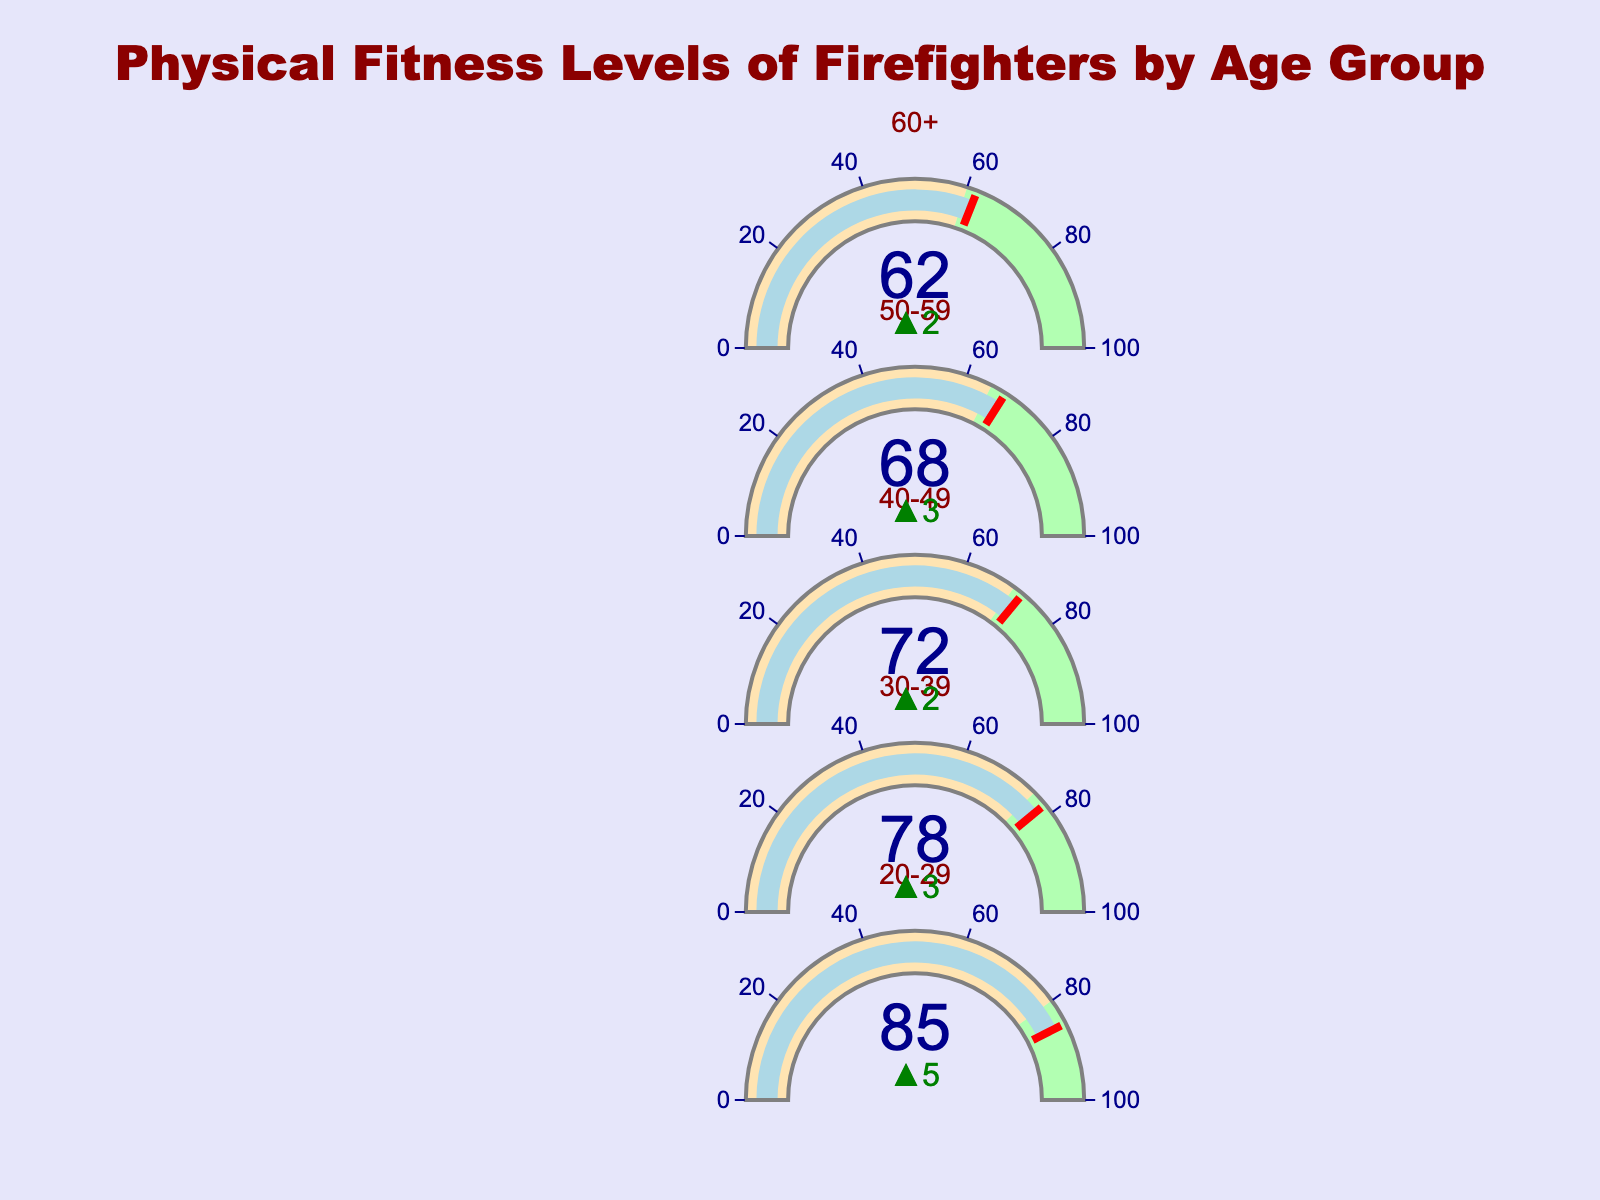What is the title of the figure? The title is provided at the top of the figure, typically in larger and bolder text compared to other text elements.
Answer: Physical Fitness Levels of Firefighters by Age Group How many age groups are analyzed in the figure? By counting the distinct titles corresponding to each age group in the list, we can determine the number of age groups.
Answer: Five For the age group 20-29, what is the current fitness level? Look at the gauge labeled "20-29" and find the indicated value within the gauge.
Answer: 85 What is the department benchmark for the age group 40-49? The benchmark is represented by a line or highlighted area within the gauge and is also displayed as a reference value.
Answer: 70 Which age group has the smallest difference between their current fitness level and the department benchmark? Calculate the difference for each age group: 20-29: 85-80=5; 30-39: 78-75=3; 40-49: 72-70=2; 50-59: 68-65=3; 60+: 62-60=2. The smallest difference is found through comparison.
Answer: 40-49 and 60+ Which age group exceeds their department benchmark by the largest margin? For each age group, determine the difference between the current fitness level and the department benchmark then identify the largest positive difference: 20-29: 85-80=5; 30-39: 78-75=3; 40-49: 72-70=2; 50-59: 68-65=3; 60+: 62-60=2. Compare these values.
Answer: 20-29 What is the average current fitness level across all age groups? Sum all current fitness levels and divide by the number of age groups: (85 + 78 + 72 + 68 + 62)/5 = 365/5.
Answer: 73 Does any age group fail to meet their department benchmark? Compare the current fitness levels to the respective department benchmarks for each age group. If the current level is below the benchmark for any group, they fail to meet it.
Answer: No How does the fitness level for the age group 50-59 compare to that of 60+? Compare the current fitness levels of these two age groups directly: 50-59 is 68, 60+ is 62.
Answer: 50-59 is higher 